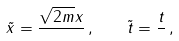<formula> <loc_0><loc_0><loc_500><loc_500>\tilde { x } = \frac { \sqrt { 2 m } x } { } \, , \quad \tilde { t } = \frac { t } { } \, ,</formula> 